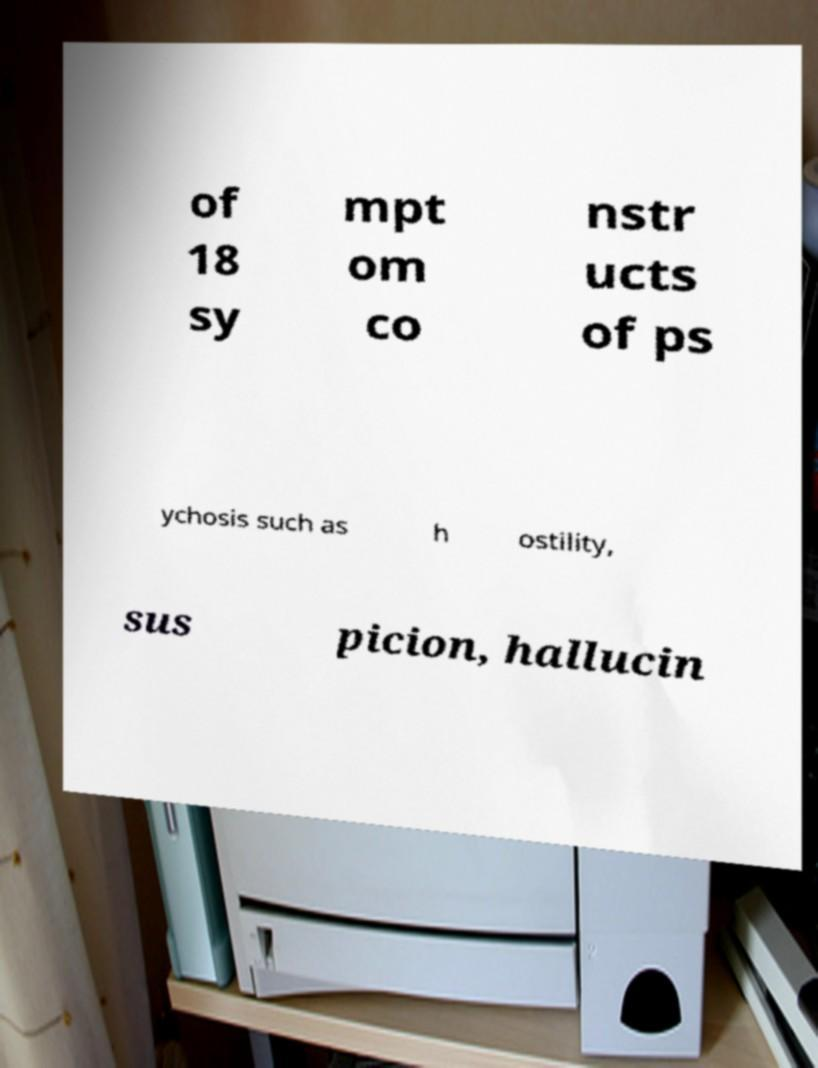Can you accurately transcribe the text from the provided image for me? of 18 sy mpt om co nstr ucts of ps ychosis such as h ostility, sus picion, hallucin 